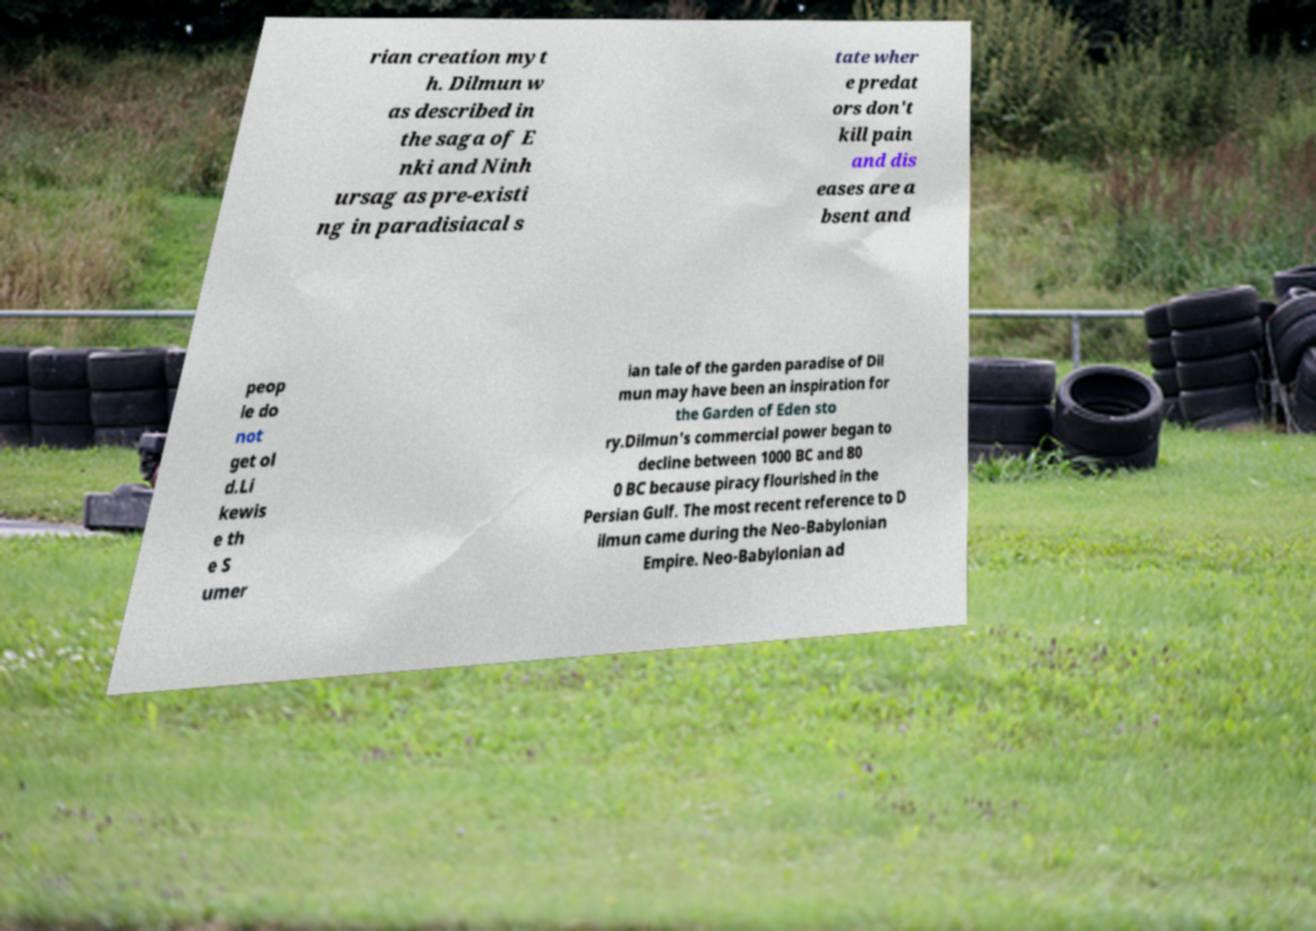Could you extract and type out the text from this image? rian creation myt h. Dilmun w as described in the saga of E nki and Ninh ursag as pre-existi ng in paradisiacal s tate wher e predat ors don't kill pain and dis eases are a bsent and peop le do not get ol d.Li kewis e th e S umer ian tale of the garden paradise of Dil mun may have been an inspiration for the Garden of Eden sto ry.Dilmun's commercial power began to decline between 1000 BC and 80 0 BC because piracy flourished in the Persian Gulf. The most recent reference to D ilmun came during the Neo-Babylonian Empire. Neo-Babylonian ad 